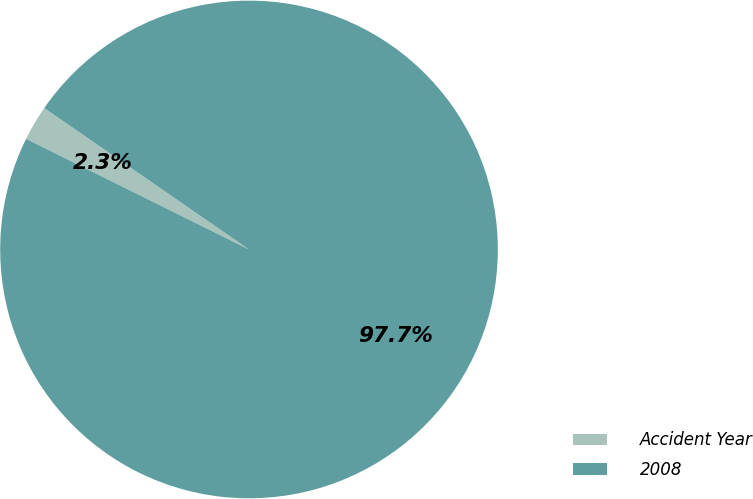Convert chart. <chart><loc_0><loc_0><loc_500><loc_500><pie_chart><fcel>Accident Year<fcel>2008<nl><fcel>2.29%<fcel>97.71%<nl></chart> 